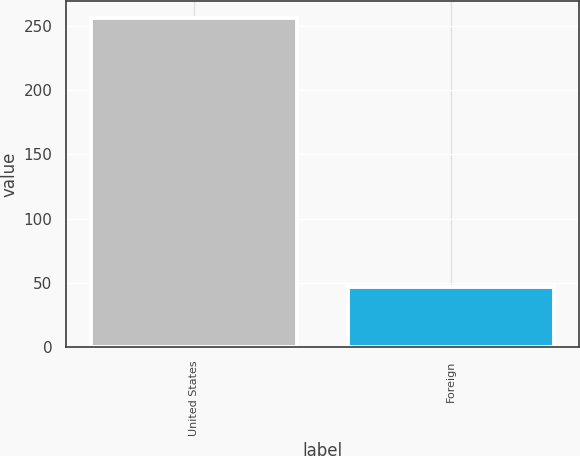<chart> <loc_0><loc_0><loc_500><loc_500><bar_chart><fcel>United States<fcel>Foreign<nl><fcel>256.2<fcel>46.5<nl></chart> 